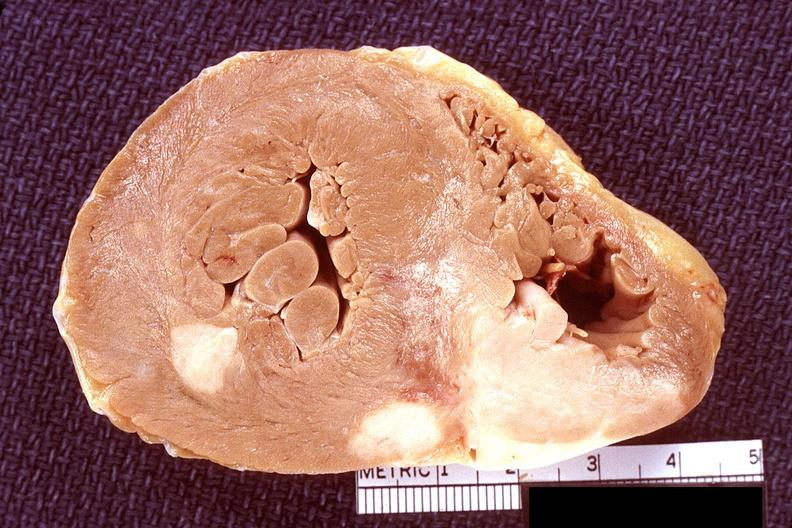where is this?
Answer the question using a single word or phrase. Heart 